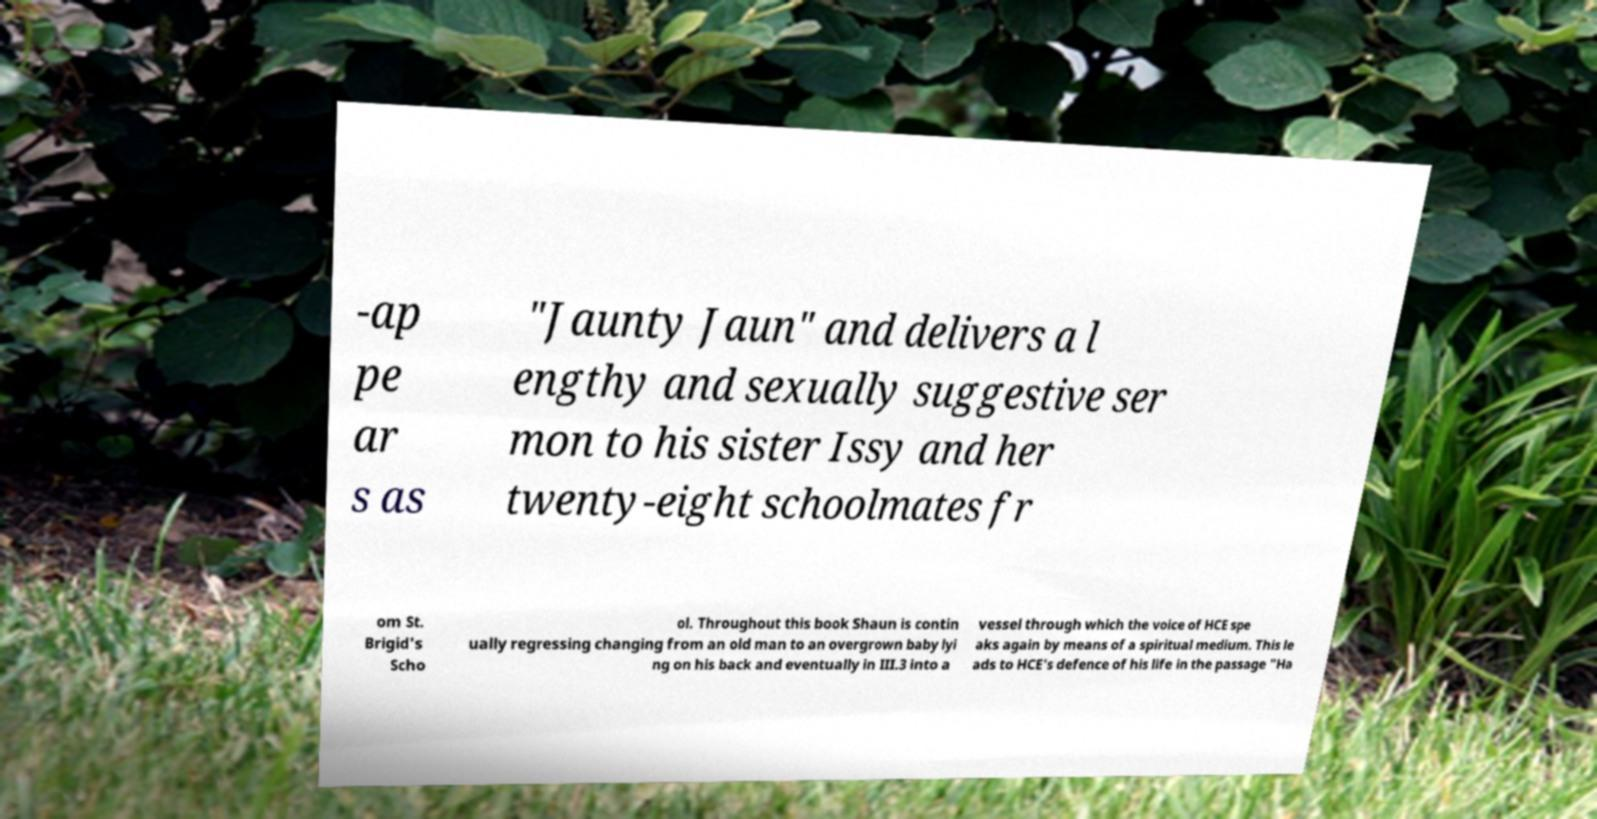For documentation purposes, I need the text within this image transcribed. Could you provide that? -ap pe ar s as "Jaunty Jaun" and delivers a l engthy and sexually suggestive ser mon to his sister Issy and her twenty-eight schoolmates fr om St. Brigid's Scho ol. Throughout this book Shaun is contin ually regressing changing from an old man to an overgrown baby lyi ng on his back and eventually in III.3 into a vessel through which the voice of HCE spe aks again by means of a spiritual medium. This le ads to HCE's defence of his life in the passage "Ha 